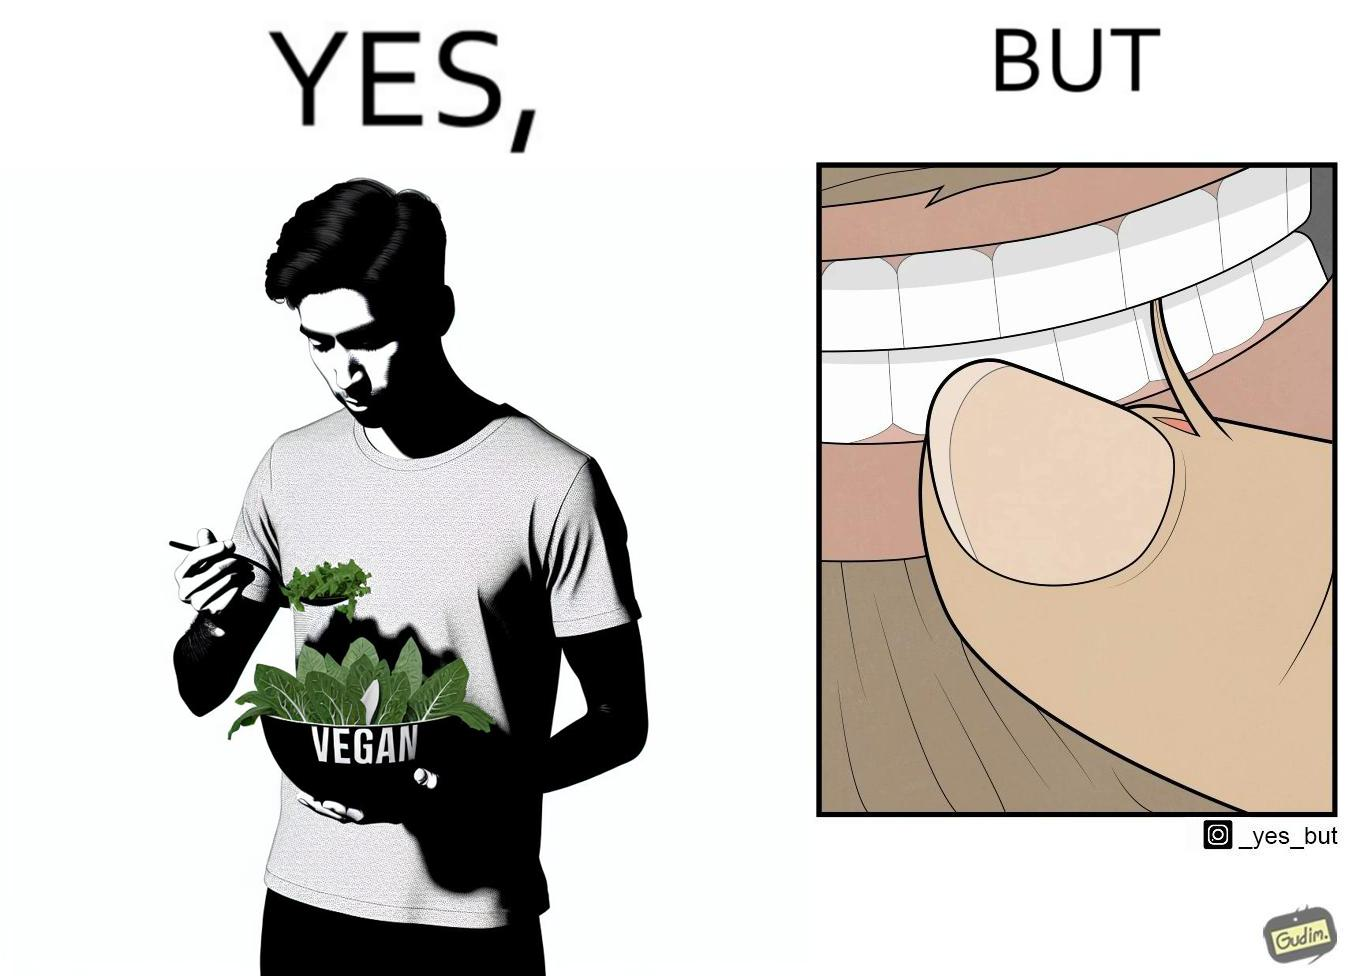Is this image satirical or non-satirical? Yes, this image is satirical. 